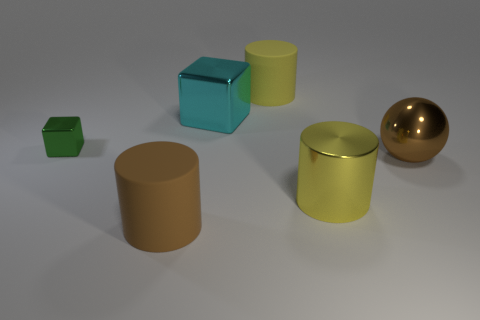Add 2 small green cubes. How many objects exist? 8 Subtract 2 cylinders. How many cylinders are left? 1 Subtract all matte cylinders. How many cylinders are left? 1 Add 2 large brown cylinders. How many large brown cylinders are left? 3 Add 5 large gray metal balls. How many large gray metal balls exist? 5 Subtract all yellow cylinders. How many cylinders are left? 1 Subtract 1 cyan blocks. How many objects are left? 5 Subtract all spheres. How many objects are left? 5 Subtract all blue spheres. Subtract all purple blocks. How many spheres are left? 1 Subtract all brown cubes. How many gray balls are left? 0 